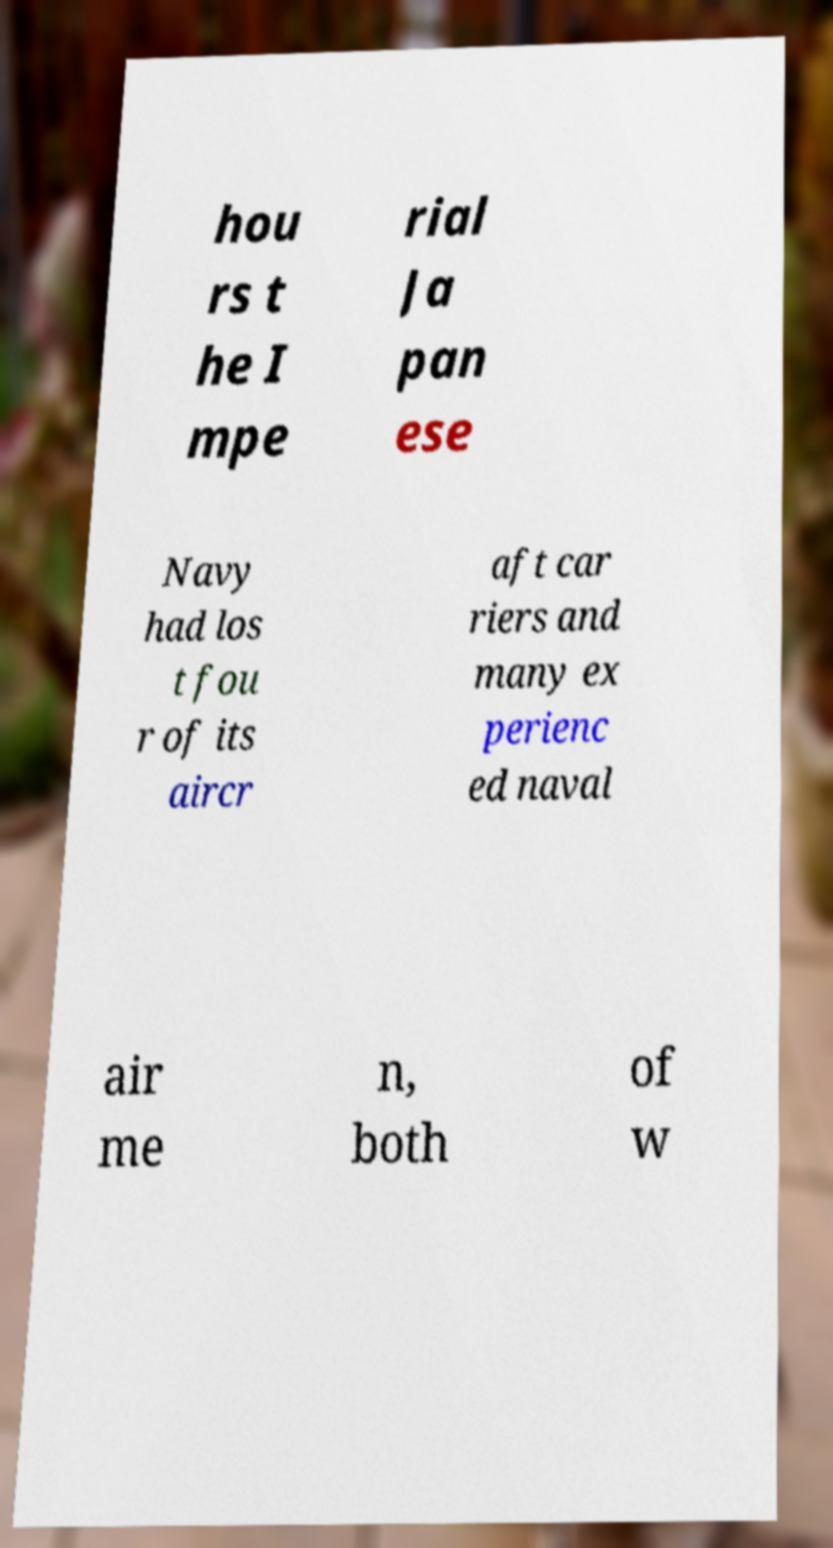There's text embedded in this image that I need extracted. Can you transcribe it verbatim? hou rs t he I mpe rial Ja pan ese Navy had los t fou r of its aircr aft car riers and many ex perienc ed naval air me n, both of w 